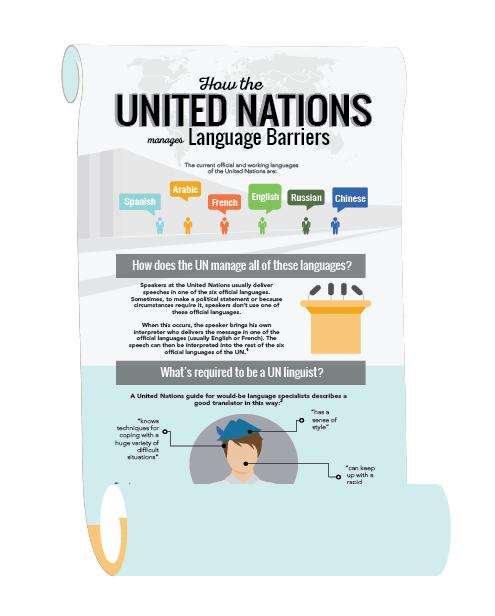Specify some key components in this picture. The United Nations has six official and working languages. There are 3 characteristics that define a UN linguist. 